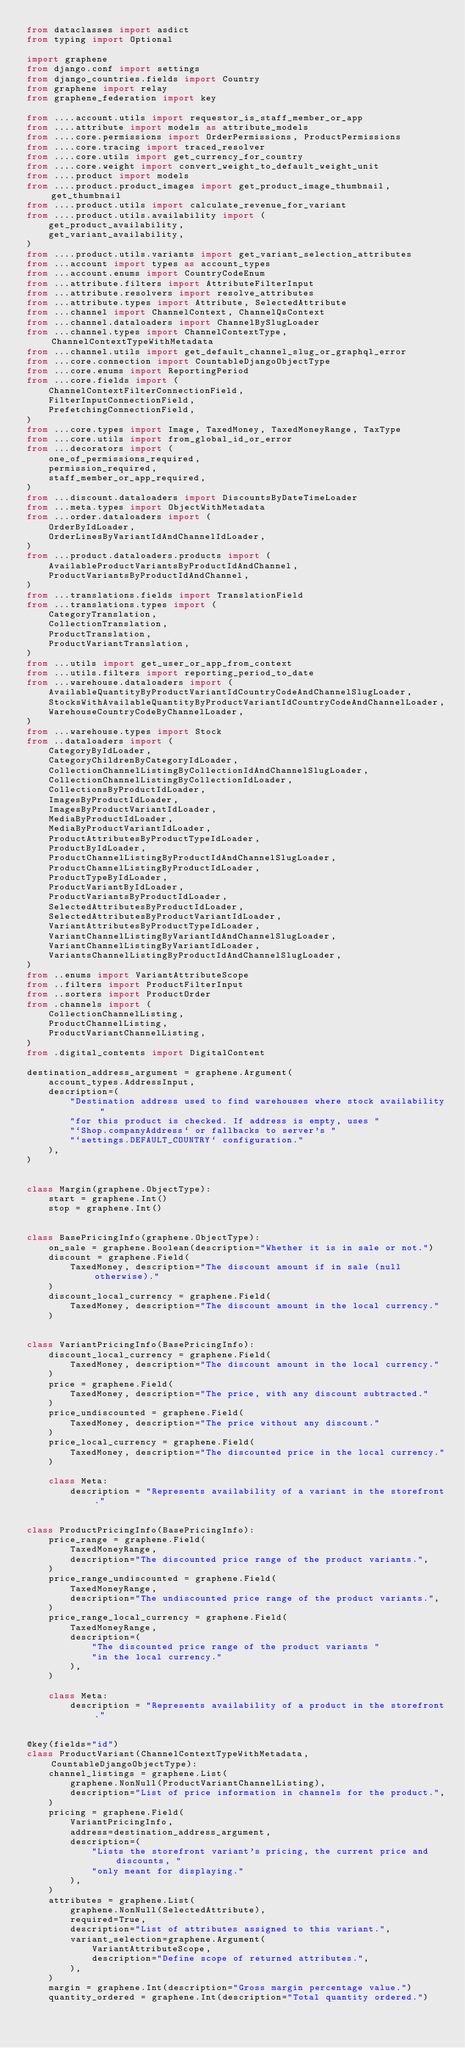<code> <loc_0><loc_0><loc_500><loc_500><_Python_>from dataclasses import asdict
from typing import Optional

import graphene
from django.conf import settings
from django_countries.fields import Country
from graphene import relay
from graphene_federation import key

from ....account.utils import requestor_is_staff_member_or_app
from ....attribute import models as attribute_models
from ....core.permissions import OrderPermissions, ProductPermissions
from ....core.tracing import traced_resolver
from ....core.utils import get_currency_for_country
from ....core.weight import convert_weight_to_default_weight_unit
from ....product import models
from ....product.product_images import get_product_image_thumbnail, get_thumbnail
from ....product.utils import calculate_revenue_for_variant
from ....product.utils.availability import (
    get_product_availability,
    get_variant_availability,
)
from ....product.utils.variants import get_variant_selection_attributes
from ...account import types as account_types
from ...account.enums import CountryCodeEnum
from ...attribute.filters import AttributeFilterInput
from ...attribute.resolvers import resolve_attributes
from ...attribute.types import Attribute, SelectedAttribute
from ...channel import ChannelContext, ChannelQsContext
from ...channel.dataloaders import ChannelBySlugLoader
from ...channel.types import ChannelContextType, ChannelContextTypeWithMetadata
from ...channel.utils import get_default_channel_slug_or_graphql_error
from ...core.connection import CountableDjangoObjectType
from ...core.enums import ReportingPeriod
from ...core.fields import (
    ChannelContextFilterConnectionField,
    FilterInputConnectionField,
    PrefetchingConnectionField,
)
from ...core.types import Image, TaxedMoney, TaxedMoneyRange, TaxType
from ...core.utils import from_global_id_or_error
from ...decorators import (
    one_of_permissions_required,
    permission_required,
    staff_member_or_app_required,
)
from ...discount.dataloaders import DiscountsByDateTimeLoader
from ...meta.types import ObjectWithMetadata
from ...order.dataloaders import (
    OrderByIdLoader,
    OrderLinesByVariantIdAndChannelIdLoader,
)
from ...product.dataloaders.products import (
    AvailableProductVariantsByProductIdAndChannel,
    ProductVariantsByProductIdAndChannel,
)
from ...translations.fields import TranslationField
from ...translations.types import (
    CategoryTranslation,
    CollectionTranslation,
    ProductTranslation,
    ProductVariantTranslation,
)
from ...utils import get_user_or_app_from_context
from ...utils.filters import reporting_period_to_date
from ...warehouse.dataloaders import (
    AvailableQuantityByProductVariantIdCountryCodeAndChannelSlugLoader,
    StocksWithAvailableQuantityByProductVariantIdCountryCodeAndChannelLoader,
    WarehouseCountryCodeByChannelLoader,
)
from ...warehouse.types import Stock
from ..dataloaders import (
    CategoryByIdLoader,
    CategoryChildrenByCategoryIdLoader,
    CollectionChannelListingByCollectionIdAndChannelSlugLoader,
    CollectionChannelListingByCollectionIdLoader,
    CollectionsByProductIdLoader,
    ImagesByProductIdLoader,
    ImagesByProductVariantIdLoader,
    MediaByProductIdLoader,
    MediaByProductVariantIdLoader,
    ProductAttributesByProductTypeIdLoader,
    ProductByIdLoader,
    ProductChannelListingByProductIdAndChannelSlugLoader,
    ProductChannelListingByProductIdLoader,
    ProductTypeByIdLoader,
    ProductVariantByIdLoader,
    ProductVariantsByProductIdLoader,
    SelectedAttributesByProductIdLoader,
    SelectedAttributesByProductVariantIdLoader,
    VariantAttributesByProductTypeIdLoader,
    VariantChannelListingByVariantIdAndChannelSlugLoader,
    VariantChannelListingByVariantIdLoader,
    VariantsChannelListingByProductIdAndChannelSlugLoader,
)
from ..enums import VariantAttributeScope
from ..filters import ProductFilterInput
from ..sorters import ProductOrder
from .channels import (
    CollectionChannelListing,
    ProductChannelListing,
    ProductVariantChannelListing,
)
from .digital_contents import DigitalContent

destination_address_argument = graphene.Argument(
    account_types.AddressInput,
    description=(
        "Destination address used to find warehouses where stock availability "
        "for this product is checked. If address is empty, uses "
        "`Shop.companyAddress` or fallbacks to server's "
        "`settings.DEFAULT_COUNTRY` configuration."
    ),
)


class Margin(graphene.ObjectType):
    start = graphene.Int()
    stop = graphene.Int()


class BasePricingInfo(graphene.ObjectType):
    on_sale = graphene.Boolean(description="Whether it is in sale or not.")
    discount = graphene.Field(
        TaxedMoney, description="The discount amount if in sale (null otherwise)."
    )
    discount_local_currency = graphene.Field(
        TaxedMoney, description="The discount amount in the local currency."
    )


class VariantPricingInfo(BasePricingInfo):
    discount_local_currency = graphene.Field(
        TaxedMoney, description="The discount amount in the local currency."
    )
    price = graphene.Field(
        TaxedMoney, description="The price, with any discount subtracted."
    )
    price_undiscounted = graphene.Field(
        TaxedMoney, description="The price without any discount."
    )
    price_local_currency = graphene.Field(
        TaxedMoney, description="The discounted price in the local currency."
    )

    class Meta:
        description = "Represents availability of a variant in the storefront."


class ProductPricingInfo(BasePricingInfo):
    price_range = graphene.Field(
        TaxedMoneyRange,
        description="The discounted price range of the product variants.",
    )
    price_range_undiscounted = graphene.Field(
        TaxedMoneyRange,
        description="The undiscounted price range of the product variants.",
    )
    price_range_local_currency = graphene.Field(
        TaxedMoneyRange,
        description=(
            "The discounted price range of the product variants "
            "in the local currency."
        ),
    )

    class Meta:
        description = "Represents availability of a product in the storefront."


@key(fields="id")
class ProductVariant(ChannelContextTypeWithMetadata, CountableDjangoObjectType):
    channel_listings = graphene.List(
        graphene.NonNull(ProductVariantChannelListing),
        description="List of price information in channels for the product.",
    )
    pricing = graphene.Field(
        VariantPricingInfo,
        address=destination_address_argument,
        description=(
            "Lists the storefront variant's pricing, the current price and discounts, "
            "only meant for displaying."
        ),
    )
    attributes = graphene.List(
        graphene.NonNull(SelectedAttribute),
        required=True,
        description="List of attributes assigned to this variant.",
        variant_selection=graphene.Argument(
            VariantAttributeScope,
            description="Define scope of returned attributes.",
        ),
    )
    margin = graphene.Int(description="Gross margin percentage value.")
    quantity_ordered = graphene.Int(description="Total quantity ordered.")</code> 